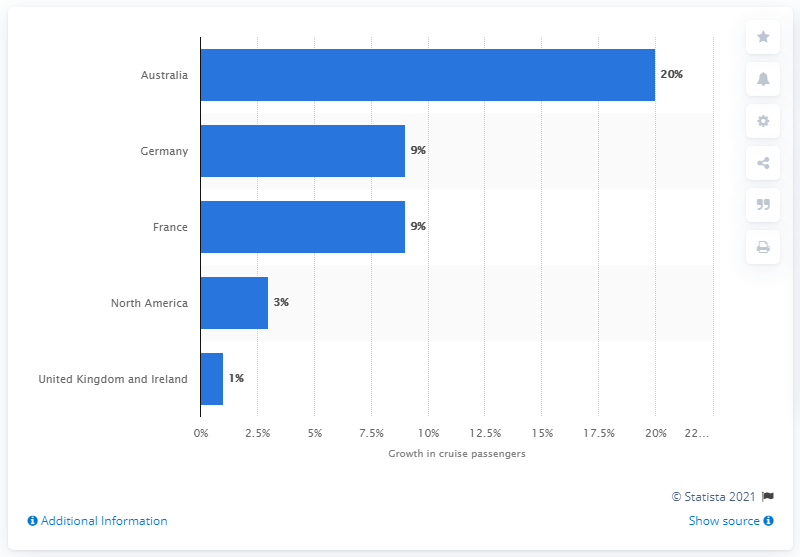Can you give me a brief analysis of the cruise industry growth trend based on this graph? The bar graph suggests a varied growth trend in the cruise industry among different regions. Australia leads with a substantial 20% increase, indicating a booming market. Both Germany and France show a healthy growth rate of 9%, which could be indicative of increasing popularity in Europe. In contrast, North America's growth is modest at 3%, and the UK/Ireland's market expansion is minimal at 1%, possibly reflecting a mature or saturated market. 